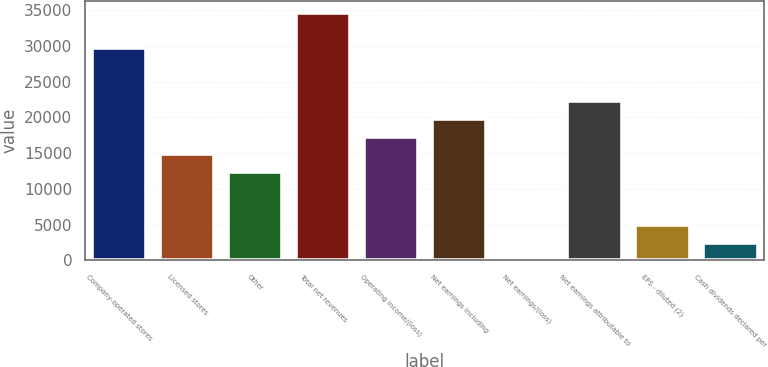<chart> <loc_0><loc_0><loc_500><loc_500><bar_chart><fcel>Company-operated stores<fcel>Licensed stores<fcel>Other<fcel>Total net revenues<fcel>Operating income/(loss)<fcel>Net earnings including<fcel>Net earnings/(loss)<fcel>Net earnings attributable to<fcel>EPS - diluted (2)<fcel>Cash dividends declared per<nl><fcel>29663.3<fcel>14831.8<fcel>12359.9<fcel>34607.2<fcel>17303.7<fcel>19775.7<fcel>0.3<fcel>22247.6<fcel>4944.14<fcel>2472.22<nl></chart> 